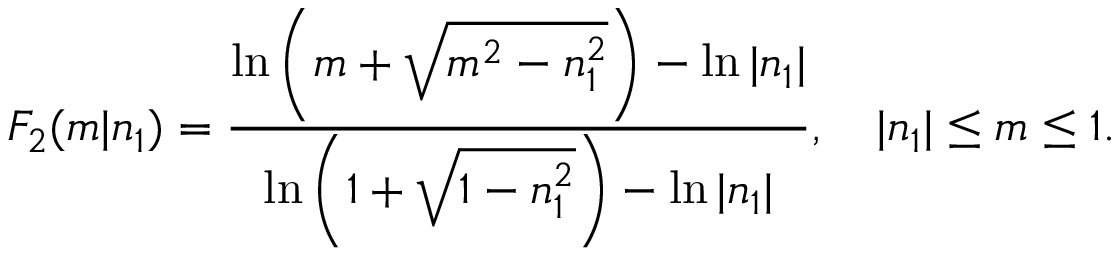Convert formula to latex. <formula><loc_0><loc_0><loc_500><loc_500>F _ { 2 } ( m | n _ { 1 } ) = \frac { \ln \left ( m + \sqrt { m ^ { 2 } - n _ { 1 } ^ { 2 } } \right ) - \ln | n _ { 1 } | } { \ln \left ( 1 + \sqrt { 1 - n _ { 1 } ^ { 2 } } \right ) - \ln | n _ { 1 } | } , \quad | n _ { 1 } | \leq m \leq 1 .</formula> 